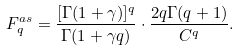Convert formula to latex. <formula><loc_0><loc_0><loc_500><loc_500>F _ { q } ^ { a s } = \frac { [ \Gamma ( 1 + \gamma ) ] ^ { q } } { \Gamma ( 1 + \gamma q ) } \cdot \frac { 2 q \Gamma ( q + 1 ) } { C ^ { q } } .</formula> 